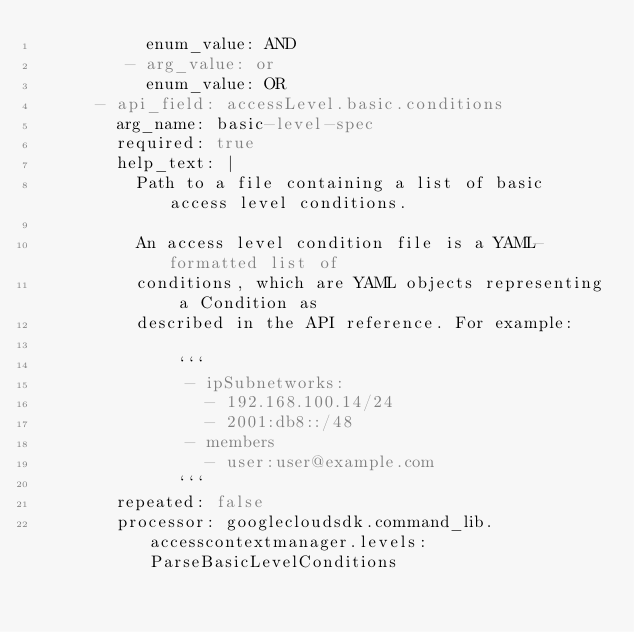Convert code to text. <code><loc_0><loc_0><loc_500><loc_500><_YAML_>           enum_value: AND
         - arg_value: or
           enum_value: OR
      - api_field: accessLevel.basic.conditions
        arg_name: basic-level-spec
        required: true
        help_text: |
          Path to a file containing a list of basic access level conditions.

          An access level condition file is a YAML-formatted list of
          conditions, which are YAML objects representing a Condition as
          described in the API reference. For example:

              ```
               - ipSubnetworks:
                 - 192.168.100.14/24
                 - 2001:db8::/48
               - members
                 - user:user@example.com
              ```
        repeated: false
        processor: googlecloudsdk.command_lib.accesscontextmanager.levels:ParseBasicLevelConditions
</code> 